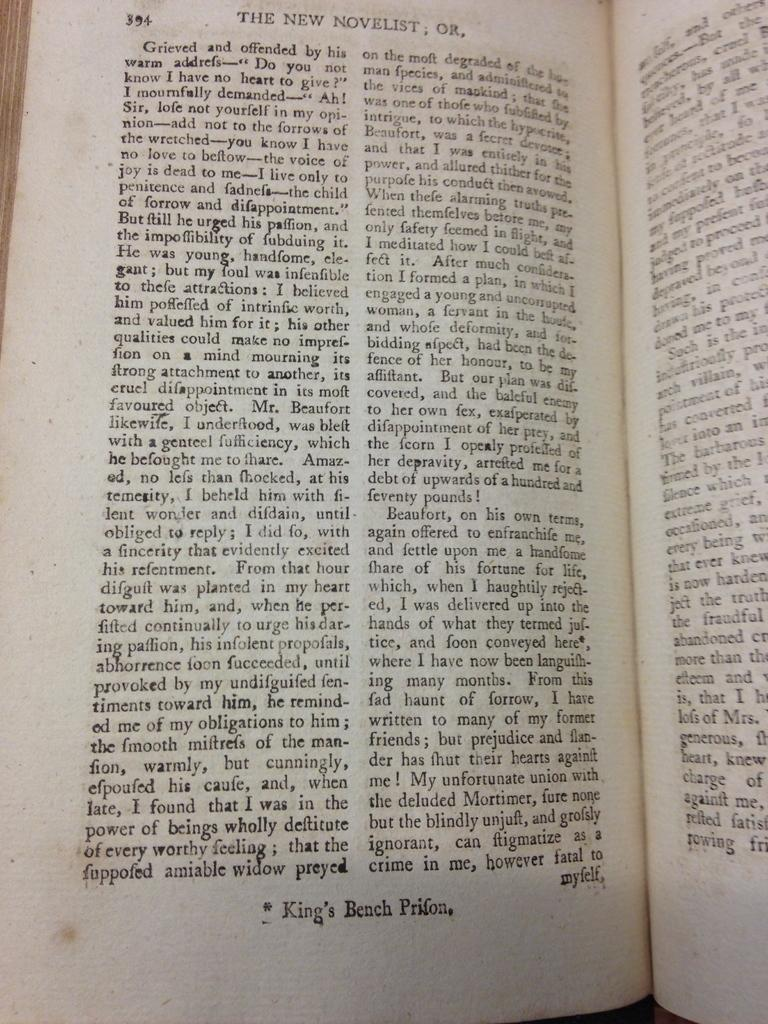<image>
Present a compact description of the photo's key features. The New Novelist book is open to page 394. 